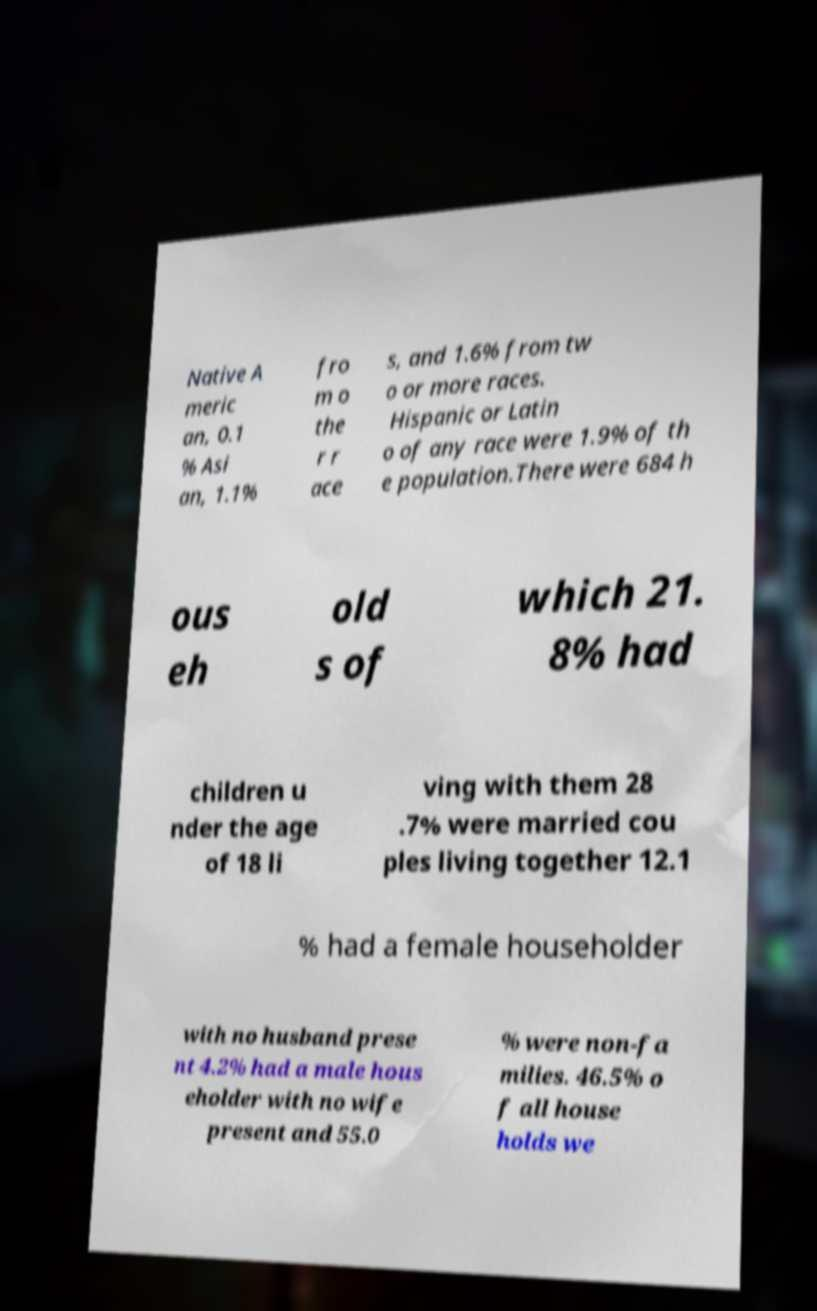Could you assist in decoding the text presented in this image and type it out clearly? Native A meric an, 0.1 % Asi an, 1.1% fro m o the r r ace s, and 1.6% from tw o or more races. Hispanic or Latin o of any race were 1.9% of th e population.There were 684 h ous eh old s of which 21. 8% had children u nder the age of 18 li ving with them 28 .7% were married cou ples living together 12.1 % had a female householder with no husband prese nt 4.2% had a male hous eholder with no wife present and 55.0 % were non-fa milies. 46.5% o f all house holds we 